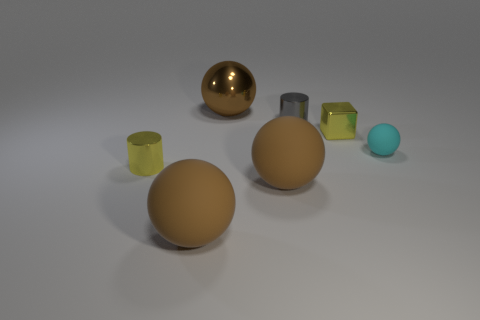Subtract all brown blocks. How many brown balls are left? 3 Subtract 1 spheres. How many spheres are left? 3 Add 1 large objects. How many objects exist? 8 Subtract all cubes. How many objects are left? 6 Subtract 0 brown cylinders. How many objects are left? 7 Subtract all cyan rubber balls. Subtract all cyan matte objects. How many objects are left? 5 Add 4 tiny matte spheres. How many tiny matte spheres are left? 5 Add 4 small cyan matte blocks. How many small cyan matte blocks exist? 4 